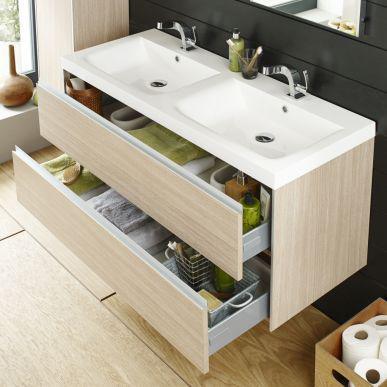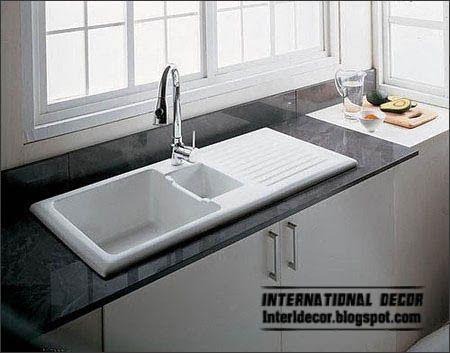The first image is the image on the left, the second image is the image on the right. For the images shown, is this caption "There are two open drawers visible." true? Answer yes or no. Yes. The first image is the image on the left, the second image is the image on the right. Considering the images on both sides, is "The bathroom on the left features a freestanding bathtub and a wide rectangular mirror over the sink vanity, and the right image shows a towel on a chrome bar alongside the vanity." valid? Answer yes or no. No. 